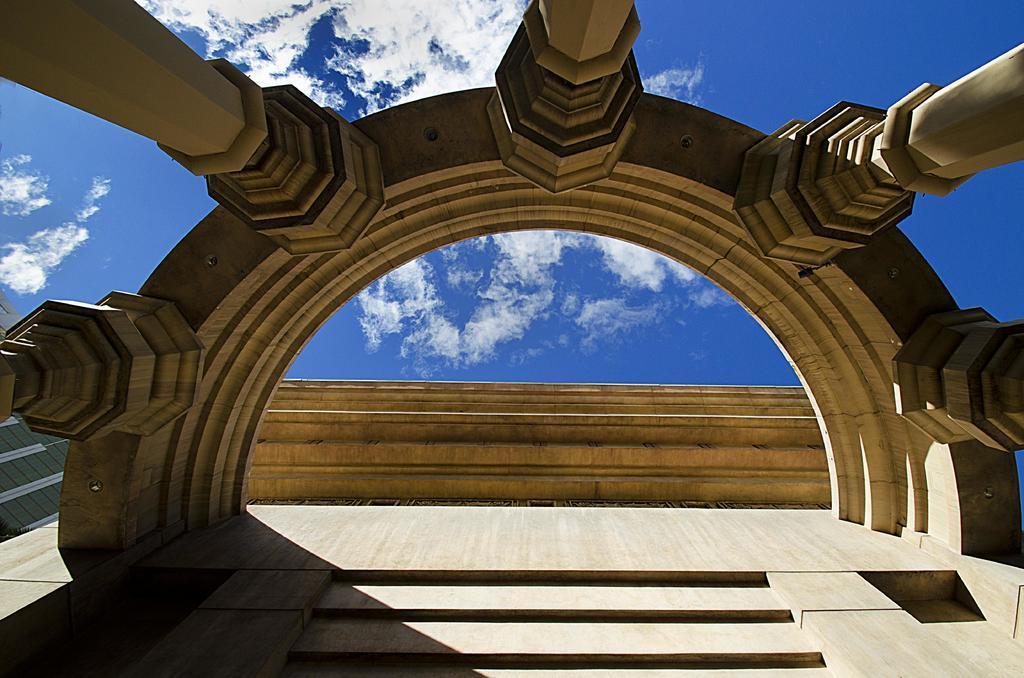In one or two sentences, can you explain what this image depicts? In this image we can see the wall and pillars with a design. And we can see the cloudy sky in the background. 